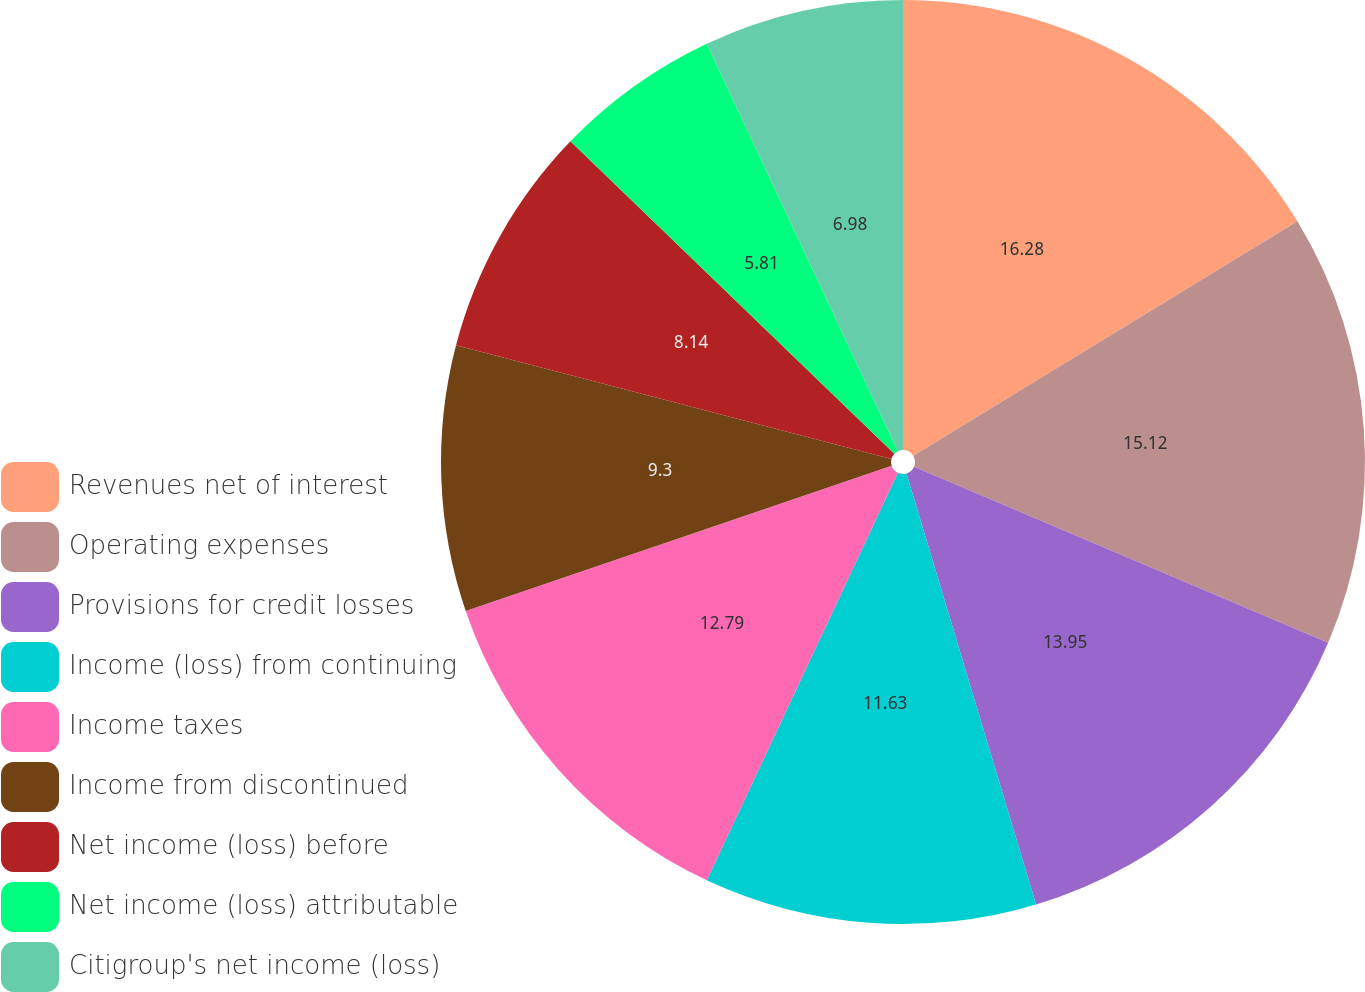Convert chart to OTSL. <chart><loc_0><loc_0><loc_500><loc_500><pie_chart><fcel>Revenues net of interest<fcel>Operating expenses<fcel>Provisions for credit losses<fcel>Income (loss) from continuing<fcel>Income taxes<fcel>Income from discontinued<fcel>Net income (loss) before<fcel>Net income (loss) attributable<fcel>Citigroup's net income (loss)<nl><fcel>16.28%<fcel>15.12%<fcel>13.95%<fcel>11.63%<fcel>12.79%<fcel>9.3%<fcel>8.14%<fcel>5.81%<fcel>6.98%<nl></chart> 